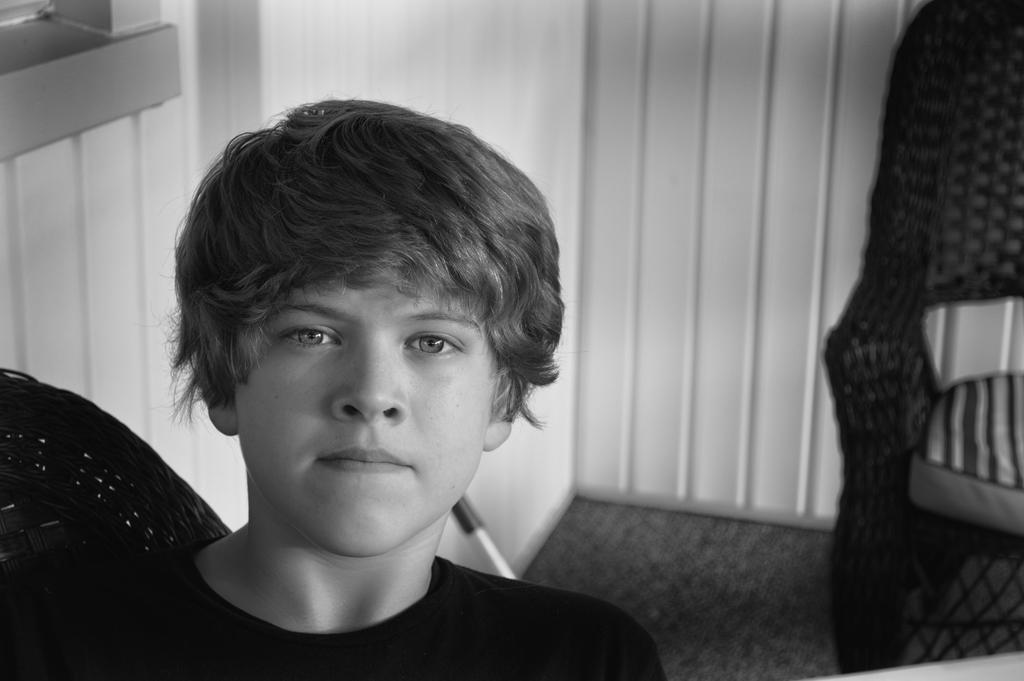Who is the main subject in the image? There is a boy in the image. What is the boy wearing? The boy is wearing a t-shirt. What is the boy doing in the image? The boy is sitting on a chair. How many chairs are visible in the image? There are two chairs visible in the image. What is the status of the other chair in the image? The chair on the floor is empty. What can be seen in the background of the image? There is a white wall and another chair in the background. How many children are crying in the image? There are no children crying in the image; it only features a boy sitting on a chair. What type of juice is the boy holding in the image? The boy is not holding any juice in the image; he is simply sitting on a chair. 